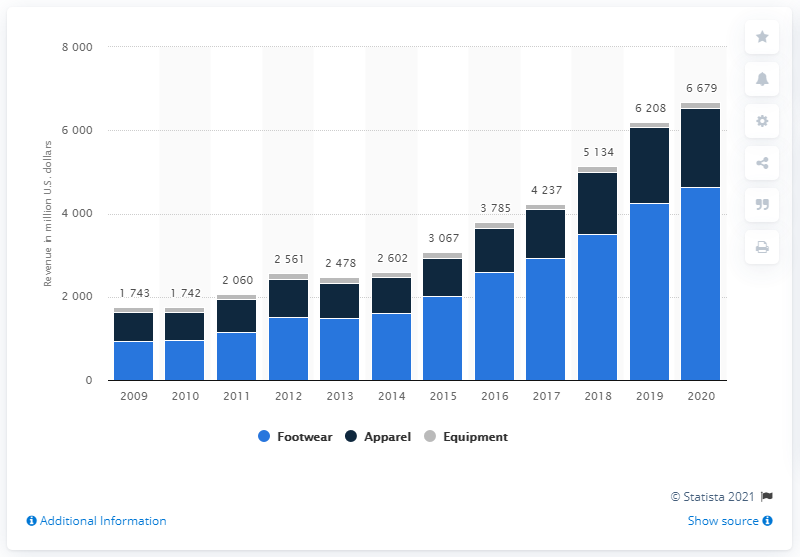Point out several critical features in this image. In 2020, Nike's footwear revenue from Greater China was approximately 4635 million dollars. 